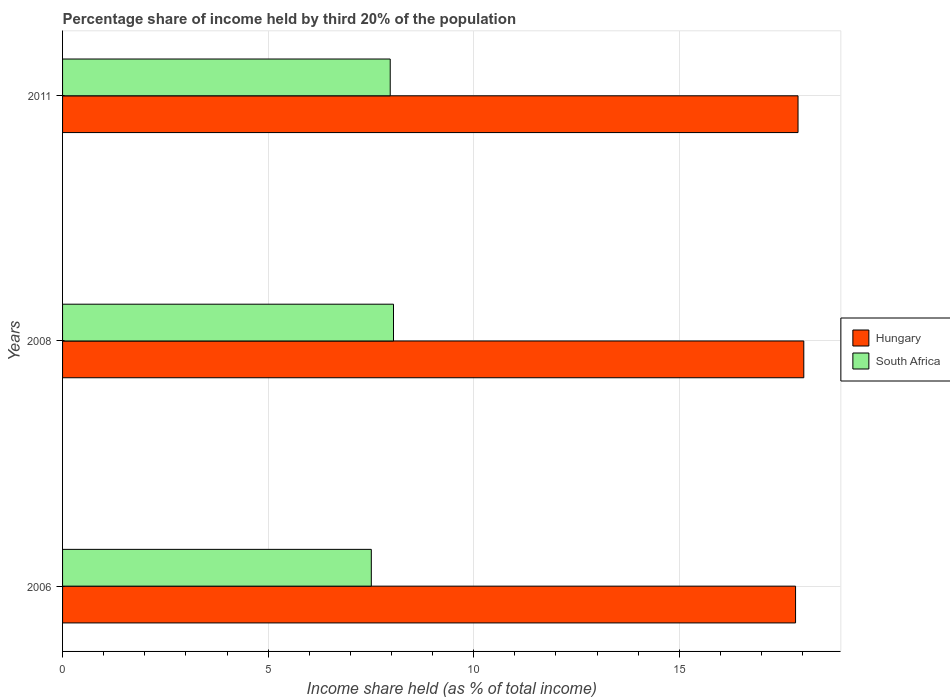Are the number of bars per tick equal to the number of legend labels?
Make the answer very short. Yes. Are the number of bars on each tick of the Y-axis equal?
Give a very brief answer. Yes. How many bars are there on the 2nd tick from the top?
Your answer should be compact. 2. How many bars are there on the 3rd tick from the bottom?
Your response must be concise. 2. What is the share of income held by third 20% of the population in Hungary in 2008?
Your response must be concise. 18.03. Across all years, what is the maximum share of income held by third 20% of the population in South Africa?
Your answer should be compact. 8.05. Across all years, what is the minimum share of income held by third 20% of the population in Hungary?
Ensure brevity in your answer.  17.83. In which year was the share of income held by third 20% of the population in South Africa minimum?
Keep it short and to the point. 2006. What is the total share of income held by third 20% of the population in South Africa in the graph?
Your response must be concise. 23.53. What is the difference between the share of income held by third 20% of the population in Hungary in 2006 and that in 2011?
Your answer should be very brief. -0.06. What is the difference between the share of income held by third 20% of the population in Hungary in 2006 and the share of income held by third 20% of the population in South Africa in 2011?
Give a very brief answer. 9.86. What is the average share of income held by third 20% of the population in South Africa per year?
Your answer should be compact. 7.84. In the year 2011, what is the difference between the share of income held by third 20% of the population in South Africa and share of income held by third 20% of the population in Hungary?
Ensure brevity in your answer.  -9.92. In how many years, is the share of income held by third 20% of the population in South Africa greater than 7 %?
Make the answer very short. 3. What is the ratio of the share of income held by third 20% of the population in South Africa in 2008 to that in 2011?
Provide a short and direct response. 1.01. Is the share of income held by third 20% of the population in Hungary in 2006 less than that in 2011?
Your answer should be compact. Yes. Is the difference between the share of income held by third 20% of the population in South Africa in 2008 and 2011 greater than the difference between the share of income held by third 20% of the population in Hungary in 2008 and 2011?
Ensure brevity in your answer.  No. What is the difference between the highest and the second highest share of income held by third 20% of the population in Hungary?
Provide a succinct answer. 0.14. What is the difference between the highest and the lowest share of income held by third 20% of the population in South Africa?
Offer a very short reply. 0.54. In how many years, is the share of income held by third 20% of the population in Hungary greater than the average share of income held by third 20% of the population in Hungary taken over all years?
Offer a very short reply. 1. Is the sum of the share of income held by third 20% of the population in Hungary in 2006 and 2008 greater than the maximum share of income held by third 20% of the population in South Africa across all years?
Give a very brief answer. Yes. What does the 1st bar from the top in 2008 represents?
Provide a short and direct response. South Africa. What does the 1st bar from the bottom in 2006 represents?
Provide a short and direct response. Hungary. How many bars are there?
Provide a succinct answer. 6. Are all the bars in the graph horizontal?
Offer a very short reply. Yes. What is the difference between two consecutive major ticks on the X-axis?
Offer a very short reply. 5. Are the values on the major ticks of X-axis written in scientific E-notation?
Your answer should be compact. No. Does the graph contain grids?
Your answer should be very brief. Yes. Where does the legend appear in the graph?
Offer a terse response. Center right. What is the title of the graph?
Offer a very short reply. Percentage share of income held by third 20% of the population. Does "Romania" appear as one of the legend labels in the graph?
Make the answer very short. No. What is the label or title of the X-axis?
Your answer should be very brief. Income share held (as % of total income). What is the label or title of the Y-axis?
Your response must be concise. Years. What is the Income share held (as % of total income) in Hungary in 2006?
Your response must be concise. 17.83. What is the Income share held (as % of total income) in South Africa in 2006?
Your answer should be very brief. 7.51. What is the Income share held (as % of total income) of Hungary in 2008?
Offer a very short reply. 18.03. What is the Income share held (as % of total income) in South Africa in 2008?
Offer a very short reply. 8.05. What is the Income share held (as % of total income) of Hungary in 2011?
Your answer should be compact. 17.89. What is the Income share held (as % of total income) in South Africa in 2011?
Offer a very short reply. 7.97. Across all years, what is the maximum Income share held (as % of total income) in Hungary?
Your answer should be compact. 18.03. Across all years, what is the maximum Income share held (as % of total income) in South Africa?
Make the answer very short. 8.05. Across all years, what is the minimum Income share held (as % of total income) of Hungary?
Your answer should be compact. 17.83. Across all years, what is the minimum Income share held (as % of total income) of South Africa?
Ensure brevity in your answer.  7.51. What is the total Income share held (as % of total income) in Hungary in the graph?
Ensure brevity in your answer.  53.75. What is the total Income share held (as % of total income) in South Africa in the graph?
Give a very brief answer. 23.53. What is the difference between the Income share held (as % of total income) in South Africa in 2006 and that in 2008?
Your answer should be very brief. -0.54. What is the difference between the Income share held (as % of total income) in Hungary in 2006 and that in 2011?
Ensure brevity in your answer.  -0.06. What is the difference between the Income share held (as % of total income) of South Africa in 2006 and that in 2011?
Offer a very short reply. -0.46. What is the difference between the Income share held (as % of total income) in Hungary in 2008 and that in 2011?
Your answer should be very brief. 0.14. What is the difference between the Income share held (as % of total income) of Hungary in 2006 and the Income share held (as % of total income) of South Africa in 2008?
Ensure brevity in your answer.  9.78. What is the difference between the Income share held (as % of total income) of Hungary in 2006 and the Income share held (as % of total income) of South Africa in 2011?
Your response must be concise. 9.86. What is the difference between the Income share held (as % of total income) of Hungary in 2008 and the Income share held (as % of total income) of South Africa in 2011?
Keep it short and to the point. 10.06. What is the average Income share held (as % of total income) in Hungary per year?
Your answer should be compact. 17.92. What is the average Income share held (as % of total income) of South Africa per year?
Your response must be concise. 7.84. In the year 2006, what is the difference between the Income share held (as % of total income) of Hungary and Income share held (as % of total income) of South Africa?
Your answer should be very brief. 10.32. In the year 2008, what is the difference between the Income share held (as % of total income) in Hungary and Income share held (as % of total income) in South Africa?
Give a very brief answer. 9.98. In the year 2011, what is the difference between the Income share held (as % of total income) of Hungary and Income share held (as % of total income) of South Africa?
Keep it short and to the point. 9.92. What is the ratio of the Income share held (as % of total income) of Hungary in 2006 to that in 2008?
Give a very brief answer. 0.99. What is the ratio of the Income share held (as % of total income) of South Africa in 2006 to that in 2008?
Your response must be concise. 0.93. What is the ratio of the Income share held (as % of total income) of South Africa in 2006 to that in 2011?
Offer a terse response. 0.94. What is the difference between the highest and the second highest Income share held (as % of total income) of Hungary?
Your answer should be very brief. 0.14. What is the difference between the highest and the lowest Income share held (as % of total income) in South Africa?
Provide a succinct answer. 0.54. 